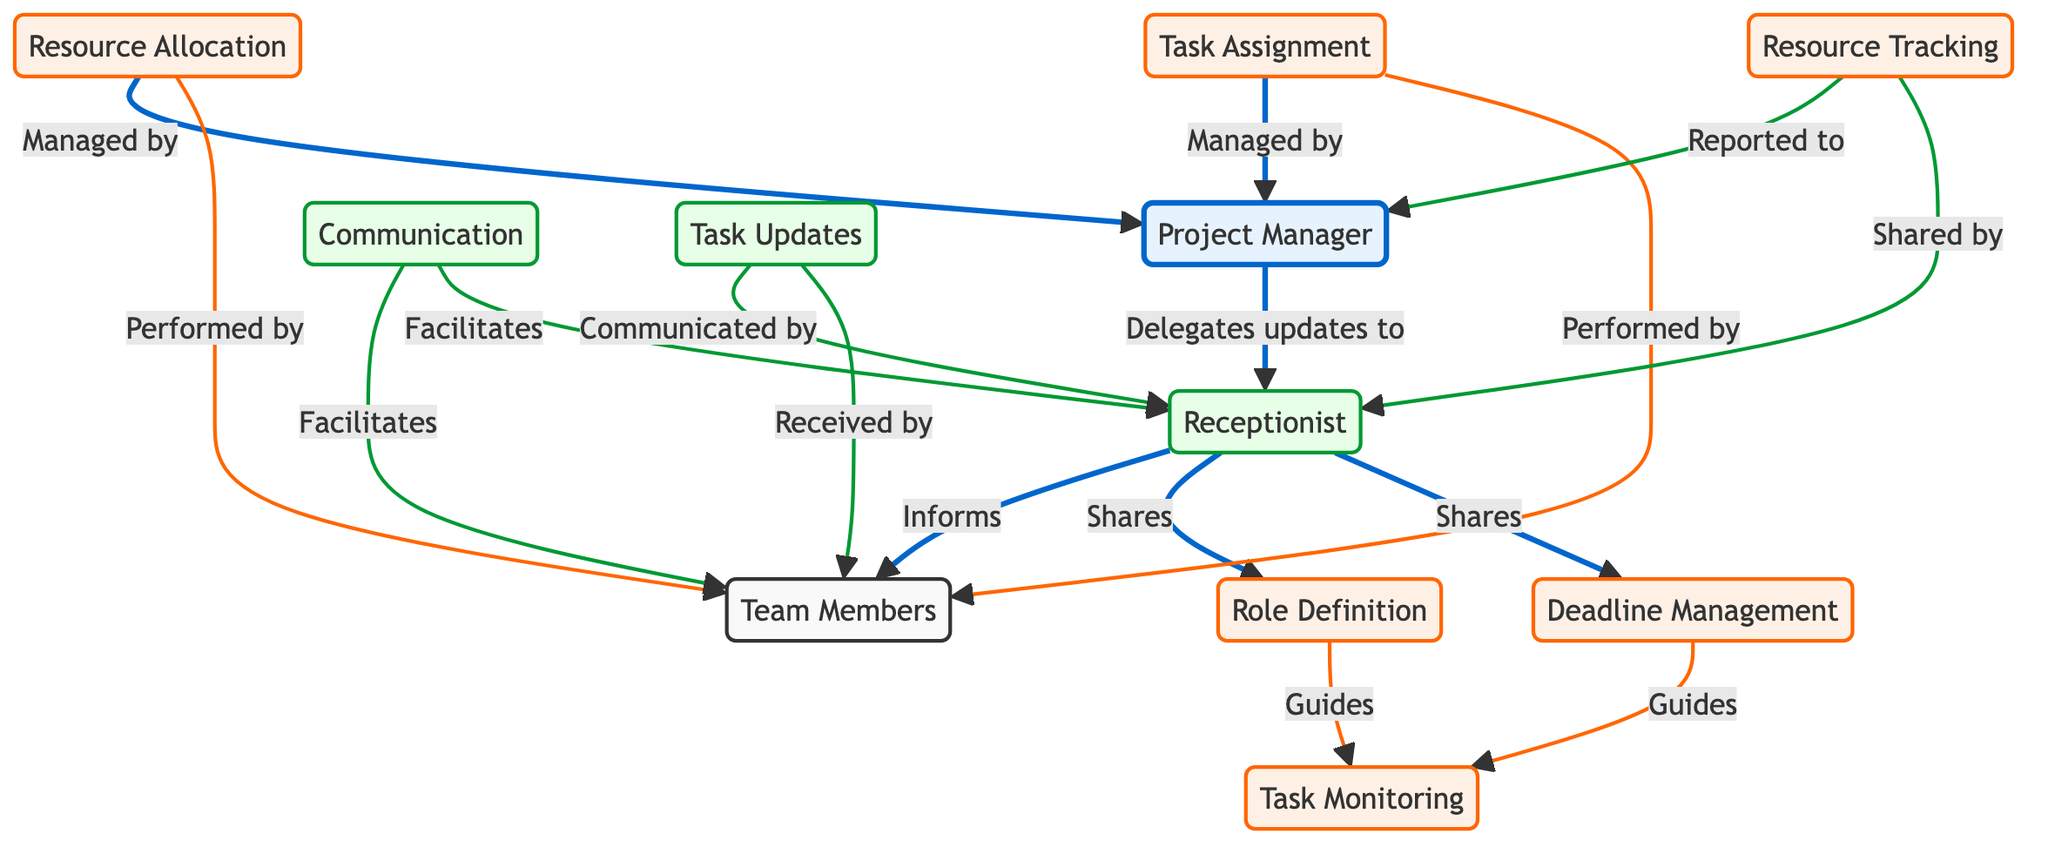What is the total number of nodes in the diagram? The diagram includes the following nodes: Resource Allocation, Task Assignment, Project Manager, Receptionist, Team Members, Role Definition, Deadline Management, Task Monitoring, Communication, Resource Tracking, and Task Updates. Counting these gives a total of 11 nodes.
Answer: 11 Which entity is responsible for managing both resource allocation and task assignment? The diagram indicates that both Resource Allocation and Task Assignment are managed by the Project Manager. This is shown by the edges connecting these processes to the Project Manager node.
Answer: Project Manager Who does the Project Manager delegate updates to? According to the diagram, the Project Manager delegates updates to the Receptionist, as indicated by the directed edge labeled "Delegates updates to."
Answer: Receptionist How does the Receptionist facilitate communication? The diagram shows that the Receptionist facilitates communication to both the Team Members and the Project Manager, illustrated by the edges connecting the Receptionist to both entities labeled "Facilitates."
Answer: Team Members and Project Manager What role does the Receptionist play in deadline management? The diagram illustrates that the Receptionist shares deadline management updates with the Team Members, as shown by the directed edge from Receptionist to Deadline Management and to Team Members.
Answer: Shares How many responsibilities does the Receptionist have in relation to the Team Members? From the diagram, the Receptionist informs Team Members, shares Role Definition, shares Deadline Management, and communicates Task Updates. This totals to four responsibilities indicated by distinct edges from the Receptionist to Team Members and other nodes.
Answer: Four Which node guides Task Monitoring? The diagram shows that both Role Definition and Deadline Management guide Task Monitoring, indicated by the directed edges labeled "Guides" connecting these nodes to Task Monitoring.
Answer: Role Definition and Deadline Management Who performs the tasks associated with Task Assignment? The Task Assignment node connects directly to Team Members with the edge labeled "Performed by," indicating that this entity is responsible for completing the task assignments.
Answer: Team Members 